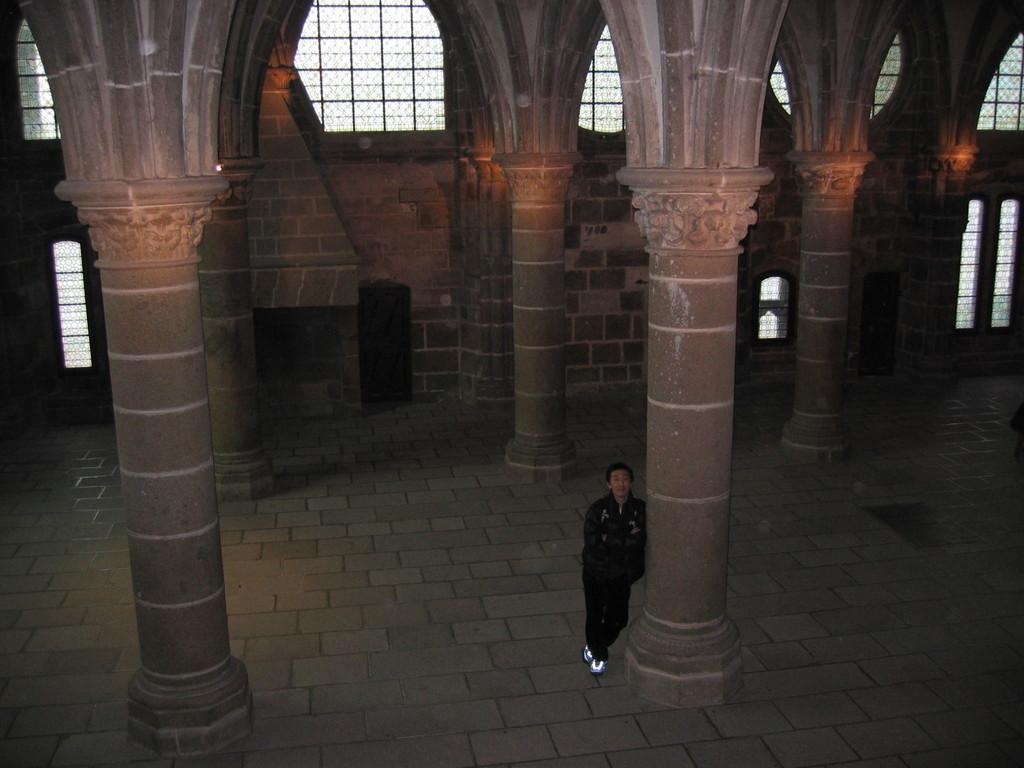Describe this image in one or two sentences. The image is taken in the hall. In the center of the image we can see a man standing and there are pillars. In the background there are windows. 